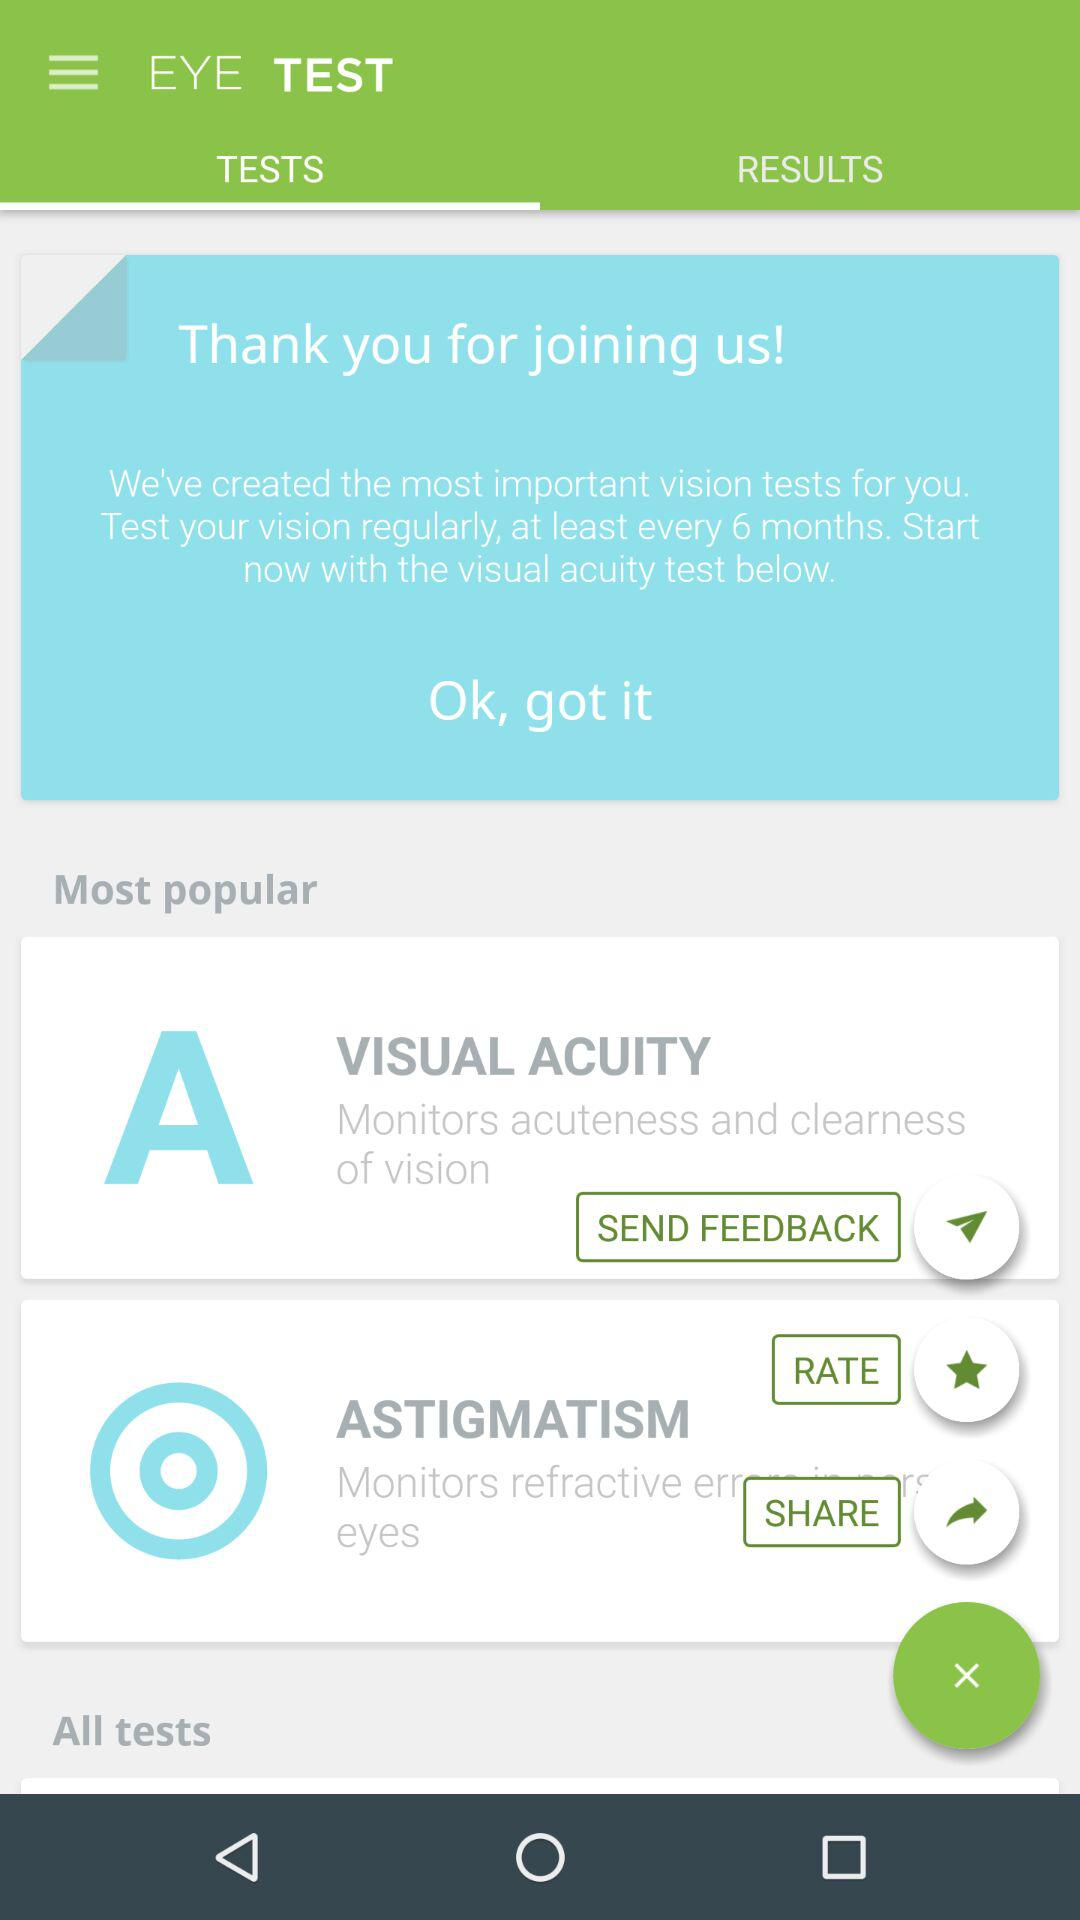What is the application name? The application name is "EYE TEST". 